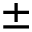Convert formula to latex. <formula><loc_0><loc_0><loc_500><loc_500>\pm</formula> 